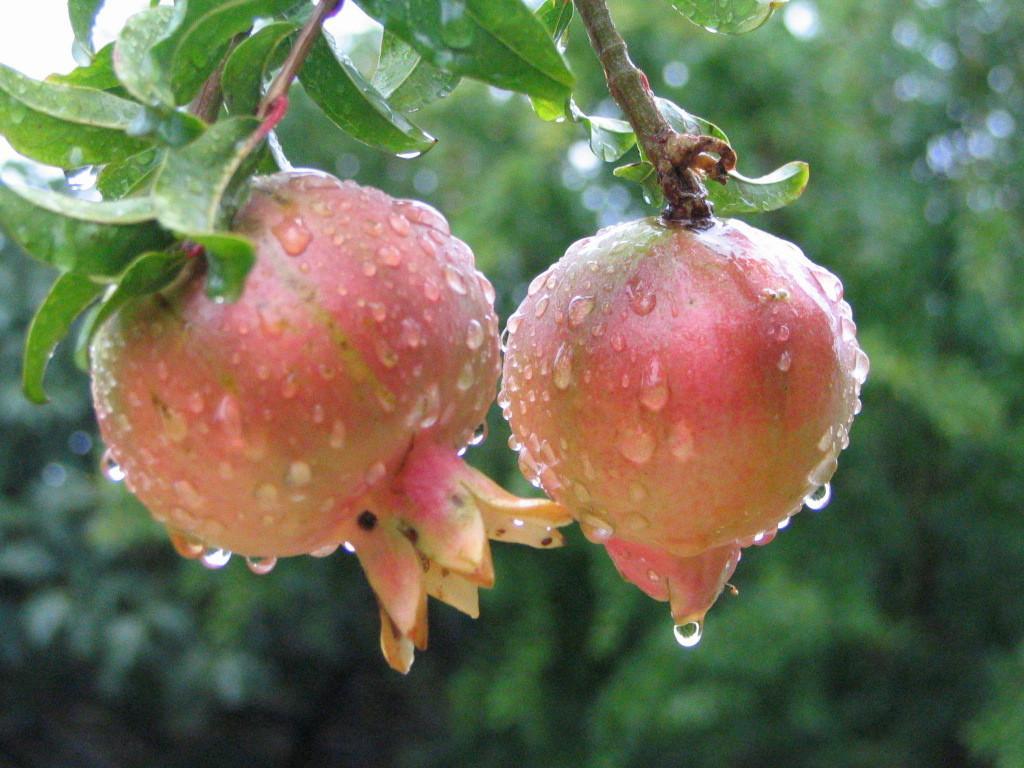Please provide a concise description of this image. In this image we can see two pomegranates to the stem. We can also see some leaves. 